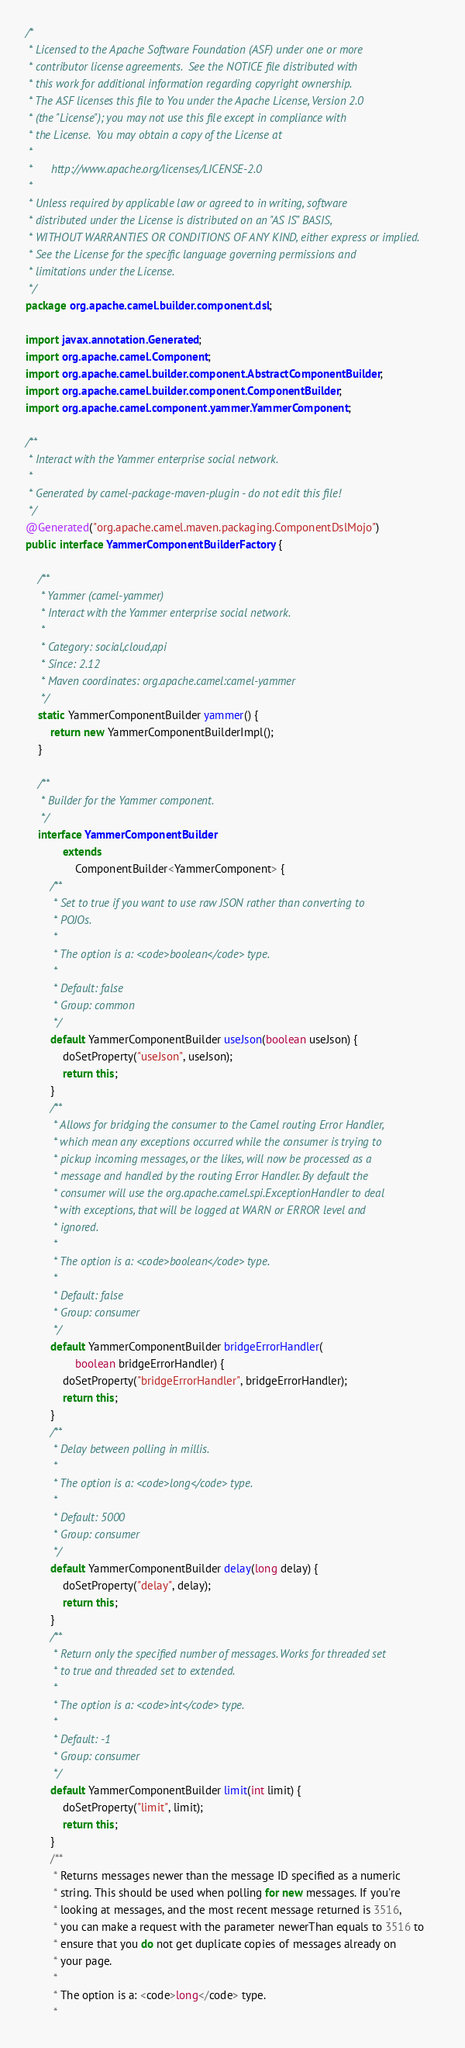Convert code to text. <code><loc_0><loc_0><loc_500><loc_500><_Java_>/*
 * Licensed to the Apache Software Foundation (ASF) under one or more
 * contributor license agreements.  See the NOTICE file distributed with
 * this work for additional information regarding copyright ownership.
 * The ASF licenses this file to You under the Apache License, Version 2.0
 * (the "License"); you may not use this file except in compliance with
 * the License.  You may obtain a copy of the License at
 *
 *      http://www.apache.org/licenses/LICENSE-2.0
 *
 * Unless required by applicable law or agreed to in writing, software
 * distributed under the License is distributed on an "AS IS" BASIS,
 * WITHOUT WARRANTIES OR CONDITIONS OF ANY KIND, either express or implied.
 * See the License for the specific language governing permissions and
 * limitations under the License.
 */
package org.apache.camel.builder.component.dsl;

import javax.annotation.Generated;
import org.apache.camel.Component;
import org.apache.camel.builder.component.AbstractComponentBuilder;
import org.apache.camel.builder.component.ComponentBuilder;
import org.apache.camel.component.yammer.YammerComponent;

/**
 * Interact with the Yammer enterprise social network.
 * 
 * Generated by camel-package-maven-plugin - do not edit this file!
 */
@Generated("org.apache.camel.maven.packaging.ComponentDslMojo")
public interface YammerComponentBuilderFactory {

    /**
     * Yammer (camel-yammer)
     * Interact with the Yammer enterprise social network.
     * 
     * Category: social,cloud,api
     * Since: 2.12
     * Maven coordinates: org.apache.camel:camel-yammer
     */
    static YammerComponentBuilder yammer() {
        return new YammerComponentBuilderImpl();
    }

    /**
     * Builder for the Yammer component.
     */
    interface YammerComponentBuilder
            extends
                ComponentBuilder<YammerComponent> {
        /**
         * Set to true if you want to use raw JSON rather than converting to
         * POJOs.
         * 
         * The option is a: <code>boolean</code> type.
         * 
         * Default: false
         * Group: common
         */
        default YammerComponentBuilder useJson(boolean useJson) {
            doSetProperty("useJson", useJson);
            return this;
        }
        /**
         * Allows for bridging the consumer to the Camel routing Error Handler,
         * which mean any exceptions occurred while the consumer is trying to
         * pickup incoming messages, or the likes, will now be processed as a
         * message and handled by the routing Error Handler. By default the
         * consumer will use the org.apache.camel.spi.ExceptionHandler to deal
         * with exceptions, that will be logged at WARN or ERROR level and
         * ignored.
         * 
         * The option is a: <code>boolean</code> type.
         * 
         * Default: false
         * Group: consumer
         */
        default YammerComponentBuilder bridgeErrorHandler(
                boolean bridgeErrorHandler) {
            doSetProperty("bridgeErrorHandler", bridgeErrorHandler);
            return this;
        }
        /**
         * Delay between polling in millis.
         * 
         * The option is a: <code>long</code> type.
         * 
         * Default: 5000
         * Group: consumer
         */
        default YammerComponentBuilder delay(long delay) {
            doSetProperty("delay", delay);
            return this;
        }
        /**
         * Return only the specified number of messages. Works for threaded set
         * to true and threaded set to extended.
         * 
         * The option is a: <code>int</code> type.
         * 
         * Default: -1
         * Group: consumer
         */
        default YammerComponentBuilder limit(int limit) {
            doSetProperty("limit", limit);
            return this;
        }
        /**
         * Returns messages newer than the message ID specified as a numeric
         * string. This should be used when polling for new messages. If you're
         * looking at messages, and the most recent message returned is 3516,
         * you can make a request with the parameter newerThan equals to 3516 to
         * ensure that you do not get duplicate copies of messages already on
         * your page.
         * 
         * The option is a: <code>long</code> type.
         * </code> 